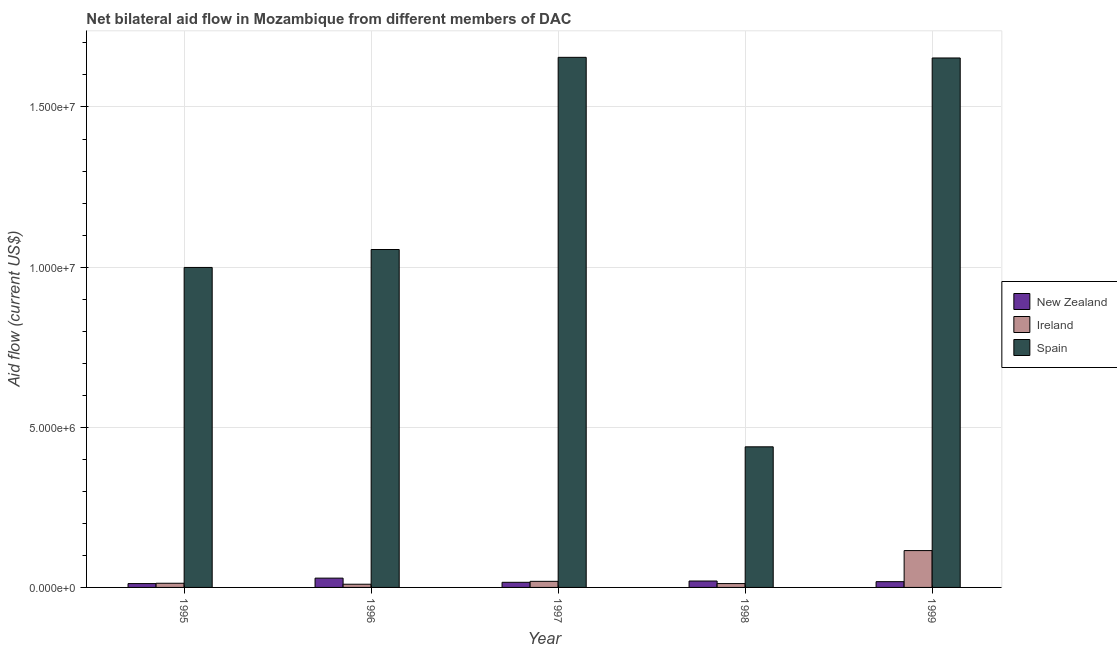Are the number of bars per tick equal to the number of legend labels?
Ensure brevity in your answer.  Yes. Are the number of bars on each tick of the X-axis equal?
Make the answer very short. Yes. How many bars are there on the 2nd tick from the left?
Your answer should be very brief. 3. How many bars are there on the 2nd tick from the right?
Offer a very short reply. 3. In how many cases, is the number of bars for a given year not equal to the number of legend labels?
Provide a short and direct response. 0. What is the amount of aid provided by new zealand in 1995?
Your response must be concise. 1.20e+05. Across all years, what is the maximum amount of aid provided by spain?
Keep it short and to the point. 1.66e+07. Across all years, what is the minimum amount of aid provided by new zealand?
Provide a short and direct response. 1.20e+05. In which year was the amount of aid provided by spain maximum?
Give a very brief answer. 1997. In which year was the amount of aid provided by new zealand minimum?
Ensure brevity in your answer.  1995. What is the total amount of aid provided by new zealand in the graph?
Your answer should be compact. 9.50e+05. What is the difference between the amount of aid provided by new zealand in 1995 and that in 1999?
Your answer should be very brief. -6.00e+04. What is the difference between the amount of aid provided by ireland in 1999 and the amount of aid provided by new zealand in 1997?
Offer a very short reply. 9.60e+05. What is the average amount of aid provided by spain per year?
Your answer should be compact. 1.16e+07. In the year 1997, what is the difference between the amount of aid provided by spain and amount of aid provided by ireland?
Offer a terse response. 0. In how many years, is the amount of aid provided by new zealand greater than 2000000 US$?
Provide a short and direct response. 0. What is the ratio of the amount of aid provided by spain in 1995 to that in 1999?
Keep it short and to the point. 0.6. Is the difference between the amount of aid provided by new zealand in 1997 and 1999 greater than the difference between the amount of aid provided by spain in 1997 and 1999?
Provide a short and direct response. No. What is the difference between the highest and the second highest amount of aid provided by new zealand?
Provide a short and direct response. 9.00e+04. What is the difference between the highest and the lowest amount of aid provided by ireland?
Keep it short and to the point. 1.05e+06. Is the sum of the amount of aid provided by ireland in 1996 and 1999 greater than the maximum amount of aid provided by new zealand across all years?
Your answer should be compact. Yes. What does the 3rd bar from the left in 1997 represents?
Ensure brevity in your answer.  Spain. Is it the case that in every year, the sum of the amount of aid provided by new zealand and amount of aid provided by ireland is greater than the amount of aid provided by spain?
Keep it short and to the point. No. How many years are there in the graph?
Make the answer very short. 5. Does the graph contain grids?
Make the answer very short. Yes. Where does the legend appear in the graph?
Your response must be concise. Center right. What is the title of the graph?
Provide a short and direct response. Net bilateral aid flow in Mozambique from different members of DAC. Does "Female employers" appear as one of the legend labels in the graph?
Ensure brevity in your answer.  No. What is the Aid flow (current US$) in Spain in 1995?
Give a very brief answer. 9.99e+06. What is the Aid flow (current US$) of Ireland in 1996?
Your response must be concise. 1.00e+05. What is the Aid flow (current US$) of Spain in 1996?
Provide a short and direct response. 1.06e+07. What is the Aid flow (current US$) of New Zealand in 1997?
Your answer should be very brief. 1.60e+05. What is the Aid flow (current US$) in Spain in 1997?
Provide a succinct answer. 1.66e+07. What is the Aid flow (current US$) in New Zealand in 1998?
Your answer should be very brief. 2.00e+05. What is the Aid flow (current US$) in Ireland in 1998?
Offer a terse response. 1.20e+05. What is the Aid flow (current US$) in Spain in 1998?
Provide a short and direct response. 4.39e+06. What is the Aid flow (current US$) in Ireland in 1999?
Your answer should be very brief. 1.15e+06. What is the Aid flow (current US$) in Spain in 1999?
Offer a terse response. 1.65e+07. Across all years, what is the maximum Aid flow (current US$) in Ireland?
Offer a very short reply. 1.15e+06. Across all years, what is the maximum Aid flow (current US$) of Spain?
Keep it short and to the point. 1.66e+07. Across all years, what is the minimum Aid flow (current US$) of Ireland?
Make the answer very short. 1.00e+05. Across all years, what is the minimum Aid flow (current US$) in Spain?
Offer a very short reply. 4.39e+06. What is the total Aid flow (current US$) in New Zealand in the graph?
Your answer should be compact. 9.50e+05. What is the total Aid flow (current US$) in Ireland in the graph?
Ensure brevity in your answer.  1.69e+06. What is the total Aid flow (current US$) in Spain in the graph?
Give a very brief answer. 5.80e+07. What is the difference between the Aid flow (current US$) of Ireland in 1995 and that in 1996?
Give a very brief answer. 3.00e+04. What is the difference between the Aid flow (current US$) in Spain in 1995 and that in 1996?
Offer a very short reply. -5.60e+05. What is the difference between the Aid flow (current US$) of Ireland in 1995 and that in 1997?
Provide a succinct answer. -6.00e+04. What is the difference between the Aid flow (current US$) of Spain in 1995 and that in 1997?
Provide a short and direct response. -6.56e+06. What is the difference between the Aid flow (current US$) in Ireland in 1995 and that in 1998?
Provide a succinct answer. 10000. What is the difference between the Aid flow (current US$) of Spain in 1995 and that in 1998?
Keep it short and to the point. 5.60e+06. What is the difference between the Aid flow (current US$) of New Zealand in 1995 and that in 1999?
Offer a very short reply. -6.00e+04. What is the difference between the Aid flow (current US$) of Ireland in 1995 and that in 1999?
Provide a short and direct response. -1.02e+06. What is the difference between the Aid flow (current US$) in Spain in 1995 and that in 1999?
Provide a succinct answer. -6.54e+06. What is the difference between the Aid flow (current US$) of New Zealand in 1996 and that in 1997?
Your answer should be very brief. 1.30e+05. What is the difference between the Aid flow (current US$) of Spain in 1996 and that in 1997?
Your answer should be very brief. -6.00e+06. What is the difference between the Aid flow (current US$) in New Zealand in 1996 and that in 1998?
Provide a succinct answer. 9.00e+04. What is the difference between the Aid flow (current US$) of Spain in 1996 and that in 1998?
Give a very brief answer. 6.16e+06. What is the difference between the Aid flow (current US$) of Ireland in 1996 and that in 1999?
Offer a terse response. -1.05e+06. What is the difference between the Aid flow (current US$) in Spain in 1996 and that in 1999?
Give a very brief answer. -5.98e+06. What is the difference between the Aid flow (current US$) in New Zealand in 1997 and that in 1998?
Your answer should be compact. -4.00e+04. What is the difference between the Aid flow (current US$) of Spain in 1997 and that in 1998?
Give a very brief answer. 1.22e+07. What is the difference between the Aid flow (current US$) in New Zealand in 1997 and that in 1999?
Provide a short and direct response. -2.00e+04. What is the difference between the Aid flow (current US$) in Ireland in 1997 and that in 1999?
Provide a succinct answer. -9.60e+05. What is the difference between the Aid flow (current US$) in Ireland in 1998 and that in 1999?
Offer a very short reply. -1.03e+06. What is the difference between the Aid flow (current US$) in Spain in 1998 and that in 1999?
Make the answer very short. -1.21e+07. What is the difference between the Aid flow (current US$) of New Zealand in 1995 and the Aid flow (current US$) of Ireland in 1996?
Your answer should be very brief. 2.00e+04. What is the difference between the Aid flow (current US$) in New Zealand in 1995 and the Aid flow (current US$) in Spain in 1996?
Give a very brief answer. -1.04e+07. What is the difference between the Aid flow (current US$) of Ireland in 1995 and the Aid flow (current US$) of Spain in 1996?
Offer a terse response. -1.04e+07. What is the difference between the Aid flow (current US$) of New Zealand in 1995 and the Aid flow (current US$) of Ireland in 1997?
Provide a short and direct response. -7.00e+04. What is the difference between the Aid flow (current US$) of New Zealand in 1995 and the Aid flow (current US$) of Spain in 1997?
Give a very brief answer. -1.64e+07. What is the difference between the Aid flow (current US$) of Ireland in 1995 and the Aid flow (current US$) of Spain in 1997?
Your answer should be compact. -1.64e+07. What is the difference between the Aid flow (current US$) of New Zealand in 1995 and the Aid flow (current US$) of Ireland in 1998?
Make the answer very short. 0. What is the difference between the Aid flow (current US$) in New Zealand in 1995 and the Aid flow (current US$) in Spain in 1998?
Provide a succinct answer. -4.27e+06. What is the difference between the Aid flow (current US$) of Ireland in 1995 and the Aid flow (current US$) of Spain in 1998?
Your response must be concise. -4.26e+06. What is the difference between the Aid flow (current US$) of New Zealand in 1995 and the Aid flow (current US$) of Ireland in 1999?
Your answer should be very brief. -1.03e+06. What is the difference between the Aid flow (current US$) of New Zealand in 1995 and the Aid flow (current US$) of Spain in 1999?
Ensure brevity in your answer.  -1.64e+07. What is the difference between the Aid flow (current US$) in Ireland in 1995 and the Aid flow (current US$) in Spain in 1999?
Ensure brevity in your answer.  -1.64e+07. What is the difference between the Aid flow (current US$) in New Zealand in 1996 and the Aid flow (current US$) in Spain in 1997?
Your answer should be very brief. -1.63e+07. What is the difference between the Aid flow (current US$) of Ireland in 1996 and the Aid flow (current US$) of Spain in 1997?
Your answer should be compact. -1.64e+07. What is the difference between the Aid flow (current US$) in New Zealand in 1996 and the Aid flow (current US$) in Ireland in 1998?
Keep it short and to the point. 1.70e+05. What is the difference between the Aid flow (current US$) of New Zealand in 1996 and the Aid flow (current US$) of Spain in 1998?
Ensure brevity in your answer.  -4.10e+06. What is the difference between the Aid flow (current US$) in Ireland in 1996 and the Aid flow (current US$) in Spain in 1998?
Keep it short and to the point. -4.29e+06. What is the difference between the Aid flow (current US$) in New Zealand in 1996 and the Aid flow (current US$) in Ireland in 1999?
Give a very brief answer. -8.60e+05. What is the difference between the Aid flow (current US$) in New Zealand in 1996 and the Aid flow (current US$) in Spain in 1999?
Your answer should be compact. -1.62e+07. What is the difference between the Aid flow (current US$) of Ireland in 1996 and the Aid flow (current US$) of Spain in 1999?
Provide a short and direct response. -1.64e+07. What is the difference between the Aid flow (current US$) in New Zealand in 1997 and the Aid flow (current US$) in Spain in 1998?
Offer a very short reply. -4.23e+06. What is the difference between the Aid flow (current US$) in Ireland in 1997 and the Aid flow (current US$) in Spain in 1998?
Keep it short and to the point. -4.20e+06. What is the difference between the Aid flow (current US$) in New Zealand in 1997 and the Aid flow (current US$) in Ireland in 1999?
Provide a short and direct response. -9.90e+05. What is the difference between the Aid flow (current US$) in New Zealand in 1997 and the Aid flow (current US$) in Spain in 1999?
Ensure brevity in your answer.  -1.64e+07. What is the difference between the Aid flow (current US$) in Ireland in 1997 and the Aid flow (current US$) in Spain in 1999?
Your answer should be compact. -1.63e+07. What is the difference between the Aid flow (current US$) in New Zealand in 1998 and the Aid flow (current US$) in Ireland in 1999?
Your answer should be compact. -9.50e+05. What is the difference between the Aid flow (current US$) of New Zealand in 1998 and the Aid flow (current US$) of Spain in 1999?
Your answer should be compact. -1.63e+07. What is the difference between the Aid flow (current US$) of Ireland in 1998 and the Aid flow (current US$) of Spain in 1999?
Offer a very short reply. -1.64e+07. What is the average Aid flow (current US$) in Ireland per year?
Your answer should be compact. 3.38e+05. What is the average Aid flow (current US$) of Spain per year?
Your response must be concise. 1.16e+07. In the year 1995, what is the difference between the Aid flow (current US$) in New Zealand and Aid flow (current US$) in Spain?
Your answer should be very brief. -9.87e+06. In the year 1995, what is the difference between the Aid flow (current US$) of Ireland and Aid flow (current US$) of Spain?
Your answer should be very brief. -9.86e+06. In the year 1996, what is the difference between the Aid flow (current US$) of New Zealand and Aid flow (current US$) of Spain?
Provide a succinct answer. -1.03e+07. In the year 1996, what is the difference between the Aid flow (current US$) of Ireland and Aid flow (current US$) of Spain?
Keep it short and to the point. -1.04e+07. In the year 1997, what is the difference between the Aid flow (current US$) in New Zealand and Aid flow (current US$) in Ireland?
Keep it short and to the point. -3.00e+04. In the year 1997, what is the difference between the Aid flow (current US$) in New Zealand and Aid flow (current US$) in Spain?
Your answer should be very brief. -1.64e+07. In the year 1997, what is the difference between the Aid flow (current US$) in Ireland and Aid flow (current US$) in Spain?
Provide a short and direct response. -1.64e+07. In the year 1998, what is the difference between the Aid flow (current US$) in New Zealand and Aid flow (current US$) in Ireland?
Provide a succinct answer. 8.00e+04. In the year 1998, what is the difference between the Aid flow (current US$) in New Zealand and Aid flow (current US$) in Spain?
Offer a terse response. -4.19e+06. In the year 1998, what is the difference between the Aid flow (current US$) in Ireland and Aid flow (current US$) in Spain?
Offer a terse response. -4.27e+06. In the year 1999, what is the difference between the Aid flow (current US$) in New Zealand and Aid flow (current US$) in Ireland?
Ensure brevity in your answer.  -9.70e+05. In the year 1999, what is the difference between the Aid flow (current US$) of New Zealand and Aid flow (current US$) of Spain?
Your answer should be very brief. -1.64e+07. In the year 1999, what is the difference between the Aid flow (current US$) of Ireland and Aid flow (current US$) of Spain?
Provide a short and direct response. -1.54e+07. What is the ratio of the Aid flow (current US$) of New Zealand in 1995 to that in 1996?
Provide a short and direct response. 0.41. What is the ratio of the Aid flow (current US$) of Ireland in 1995 to that in 1996?
Make the answer very short. 1.3. What is the ratio of the Aid flow (current US$) in Spain in 1995 to that in 1996?
Provide a short and direct response. 0.95. What is the ratio of the Aid flow (current US$) in New Zealand in 1995 to that in 1997?
Offer a very short reply. 0.75. What is the ratio of the Aid flow (current US$) in Ireland in 1995 to that in 1997?
Offer a very short reply. 0.68. What is the ratio of the Aid flow (current US$) in Spain in 1995 to that in 1997?
Give a very brief answer. 0.6. What is the ratio of the Aid flow (current US$) of New Zealand in 1995 to that in 1998?
Give a very brief answer. 0.6. What is the ratio of the Aid flow (current US$) in Ireland in 1995 to that in 1998?
Keep it short and to the point. 1.08. What is the ratio of the Aid flow (current US$) in Spain in 1995 to that in 1998?
Provide a succinct answer. 2.28. What is the ratio of the Aid flow (current US$) of New Zealand in 1995 to that in 1999?
Provide a short and direct response. 0.67. What is the ratio of the Aid flow (current US$) of Ireland in 1995 to that in 1999?
Provide a short and direct response. 0.11. What is the ratio of the Aid flow (current US$) of Spain in 1995 to that in 1999?
Give a very brief answer. 0.6. What is the ratio of the Aid flow (current US$) in New Zealand in 1996 to that in 1997?
Your answer should be very brief. 1.81. What is the ratio of the Aid flow (current US$) in Ireland in 1996 to that in 1997?
Provide a succinct answer. 0.53. What is the ratio of the Aid flow (current US$) of Spain in 1996 to that in 1997?
Ensure brevity in your answer.  0.64. What is the ratio of the Aid flow (current US$) of New Zealand in 1996 to that in 1998?
Ensure brevity in your answer.  1.45. What is the ratio of the Aid flow (current US$) of Ireland in 1996 to that in 1998?
Provide a succinct answer. 0.83. What is the ratio of the Aid flow (current US$) in Spain in 1996 to that in 1998?
Provide a short and direct response. 2.4. What is the ratio of the Aid flow (current US$) of New Zealand in 1996 to that in 1999?
Your answer should be compact. 1.61. What is the ratio of the Aid flow (current US$) of Ireland in 1996 to that in 1999?
Keep it short and to the point. 0.09. What is the ratio of the Aid flow (current US$) in Spain in 1996 to that in 1999?
Your answer should be very brief. 0.64. What is the ratio of the Aid flow (current US$) of New Zealand in 1997 to that in 1998?
Your answer should be very brief. 0.8. What is the ratio of the Aid flow (current US$) in Ireland in 1997 to that in 1998?
Your answer should be very brief. 1.58. What is the ratio of the Aid flow (current US$) of Spain in 1997 to that in 1998?
Make the answer very short. 3.77. What is the ratio of the Aid flow (current US$) of Ireland in 1997 to that in 1999?
Your response must be concise. 0.17. What is the ratio of the Aid flow (current US$) in Ireland in 1998 to that in 1999?
Make the answer very short. 0.1. What is the ratio of the Aid flow (current US$) in Spain in 1998 to that in 1999?
Keep it short and to the point. 0.27. What is the difference between the highest and the second highest Aid flow (current US$) in New Zealand?
Your response must be concise. 9.00e+04. What is the difference between the highest and the second highest Aid flow (current US$) of Ireland?
Provide a short and direct response. 9.60e+05. What is the difference between the highest and the second highest Aid flow (current US$) in Spain?
Your answer should be compact. 2.00e+04. What is the difference between the highest and the lowest Aid flow (current US$) of Ireland?
Make the answer very short. 1.05e+06. What is the difference between the highest and the lowest Aid flow (current US$) of Spain?
Keep it short and to the point. 1.22e+07. 